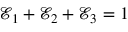<formula> <loc_0><loc_0><loc_500><loc_500>\ m a t h s c r { E } _ { 1 } + \ m a t h s c r { E } _ { 2 } + \ m a t h s c r { E } _ { 3 } = 1</formula> 